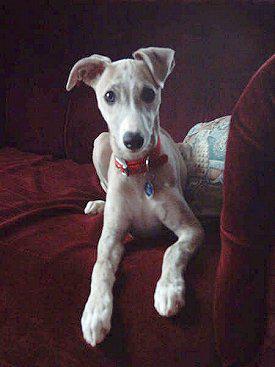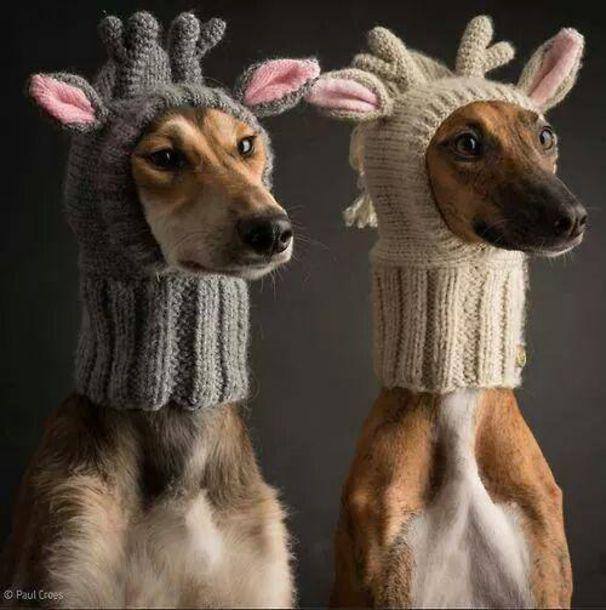The first image is the image on the left, the second image is the image on the right. Considering the images on both sides, is "An image contains a pair of similarly-posed dogs wearing similar items around their necks." valid? Answer yes or no. Yes. The first image is the image on the left, the second image is the image on the right. Given the left and right images, does the statement "The right image contains exactly two dogs seated next to each other looking towards the right." hold true? Answer yes or no. Yes. 